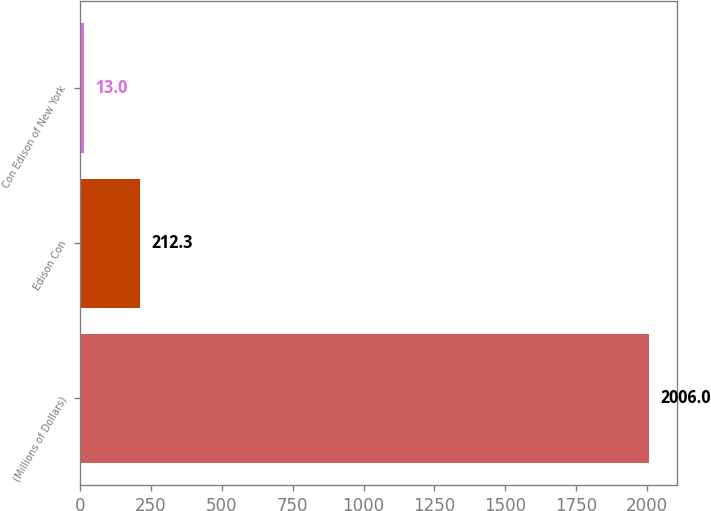<chart> <loc_0><loc_0><loc_500><loc_500><bar_chart><fcel>(Millions of Dollars)<fcel>Edison Con<fcel>Con Edison of New York<nl><fcel>2006<fcel>212.3<fcel>13<nl></chart> 